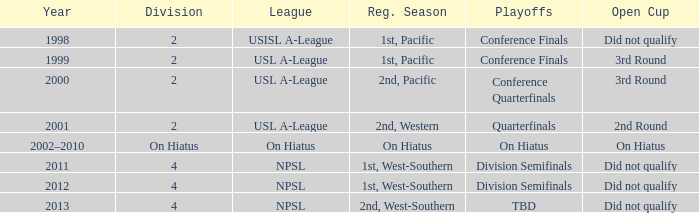Which open cup took place in 2012? Did not qualify. 